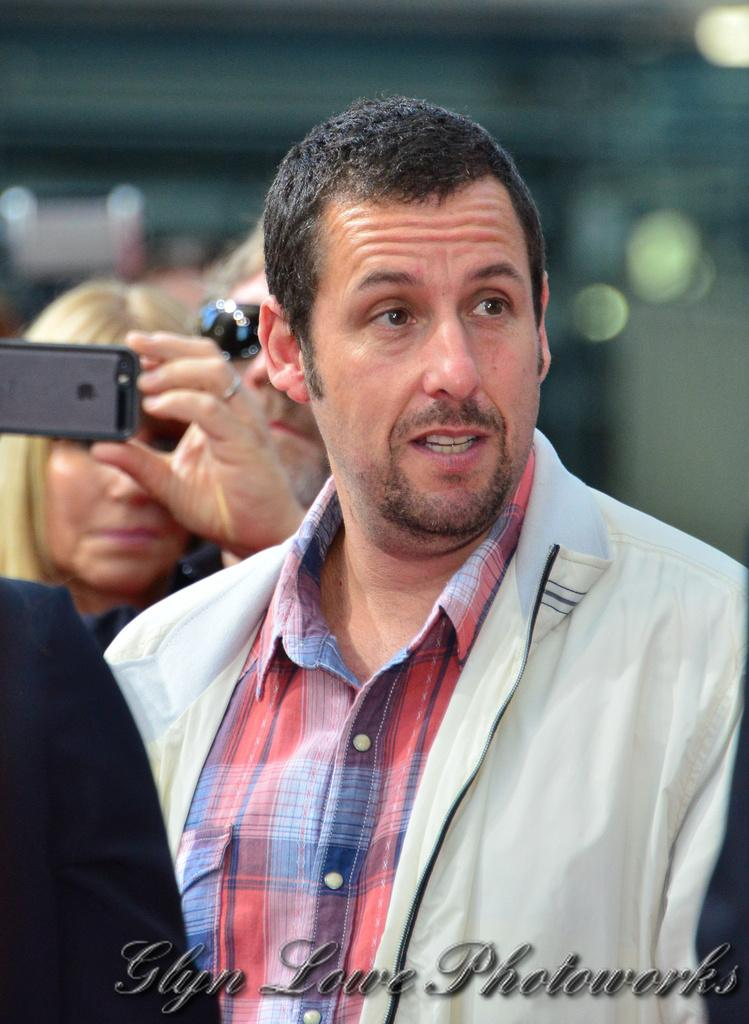How many people are in the image? There are people in the image. What is one person doing in the image? One person is looking at something. Can you describe the person in the background? The person in the background is wearing goggles and holding a mobile phone. What type of street can be seen in the image? There is no street visible in the image. 